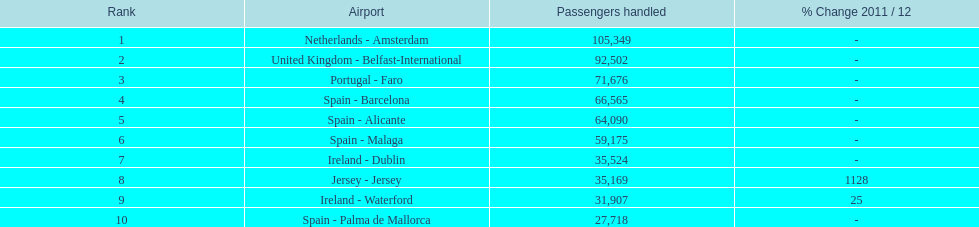How many airports can be found on the list? 10. Would you be able to parse every entry in this table? {'header': ['Rank', 'Airport', 'Passengers handled', '% Change 2011 / 12'], 'rows': [['1', 'Netherlands - Amsterdam', '105,349', '-'], ['2', 'United Kingdom - Belfast-International', '92,502', '-'], ['3', 'Portugal - Faro', '71,676', '-'], ['4', 'Spain - Barcelona', '66,565', '-'], ['5', 'Spain - Alicante', '64,090', '-'], ['6', 'Spain - Malaga', '59,175', '-'], ['7', 'Ireland - Dublin', '35,524', '-'], ['8', 'Jersey - Jersey', '35,169', '1128'], ['9', 'Ireland - Waterford', '31,907', '25'], ['10', 'Spain - Palma de Mallorca', '27,718', '-']]} 